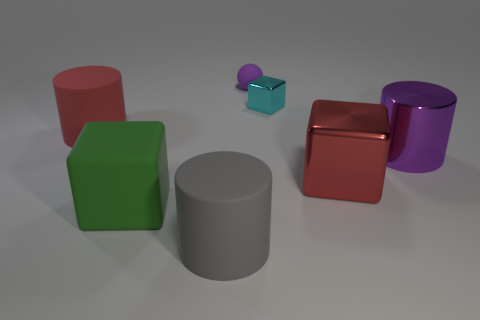Add 3 cyan matte cylinders. How many objects exist? 10 Subtract all purple cylinders. How many cylinders are left? 2 Subtract 2 blocks. How many blocks are left? 1 Subtract all cylinders. How many objects are left? 4 Subtract all gray cylinders. How many cylinders are left? 2 Subtract all blue cylinders. Subtract all gray blocks. How many cylinders are left? 3 Subtract all green cylinders. How many red cubes are left? 1 Add 6 small objects. How many small objects are left? 8 Add 4 large red metallic cubes. How many large red metallic cubes exist? 5 Subtract 0 yellow cylinders. How many objects are left? 7 